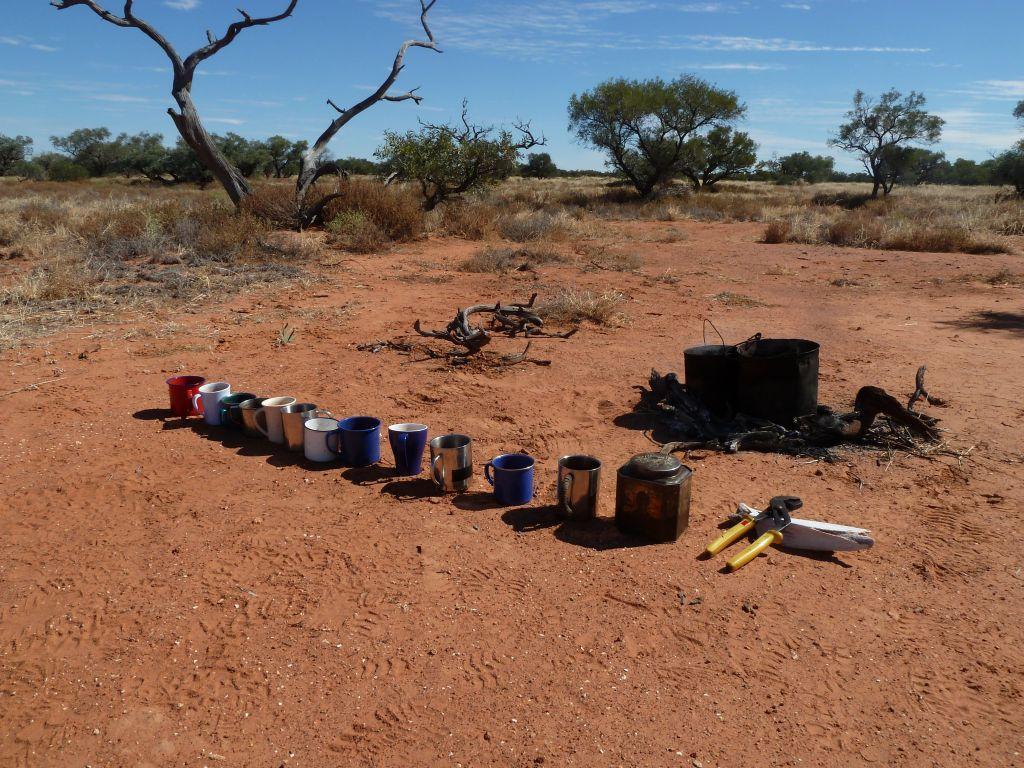In one or two sentences, can you explain what this image depicts? In the image there are few coffee cups,jars and plier on the land, in the back there are trees and plants and above its sky. 